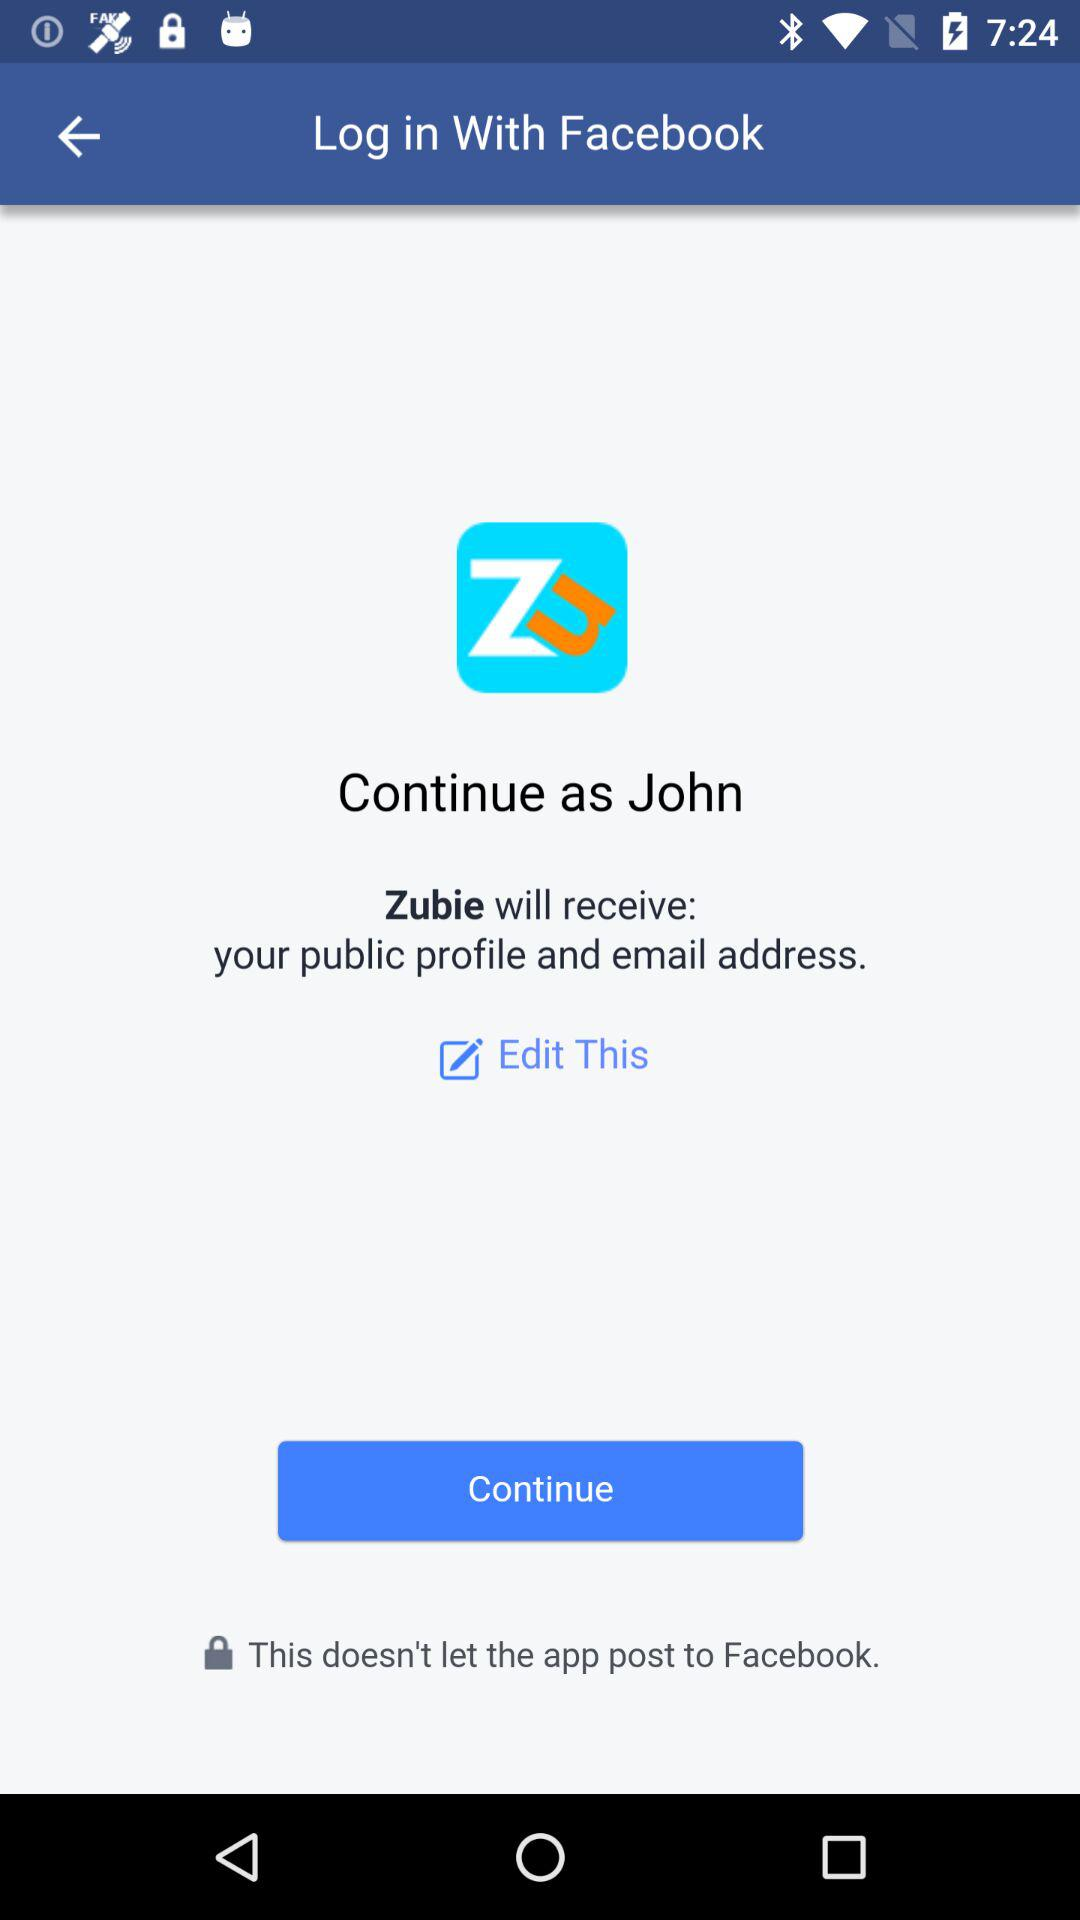What is the given login name? The given login name is John. 